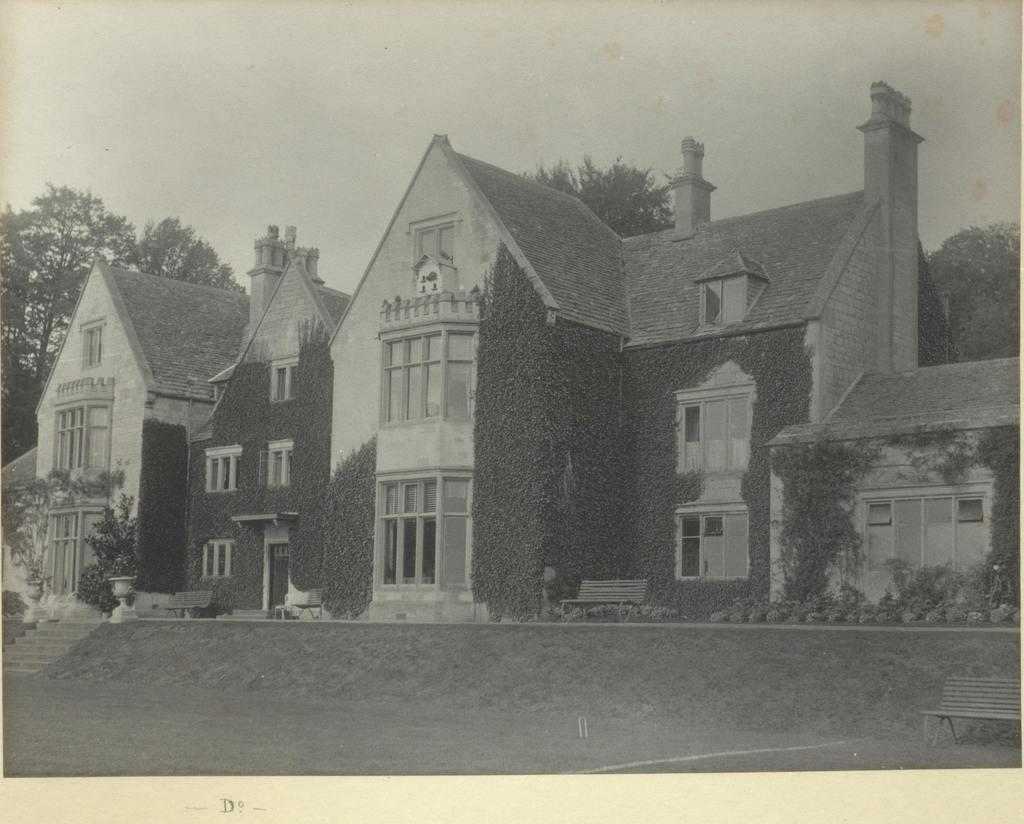What is the color scheme of the image? The image is black and white. What can be seen in the center of the image? There are trees and a building in the center of the image. How many cherries are hanging from the trees in the image? There are no cherries present in the image, as it is a black and white image with trees and a building in the center. 